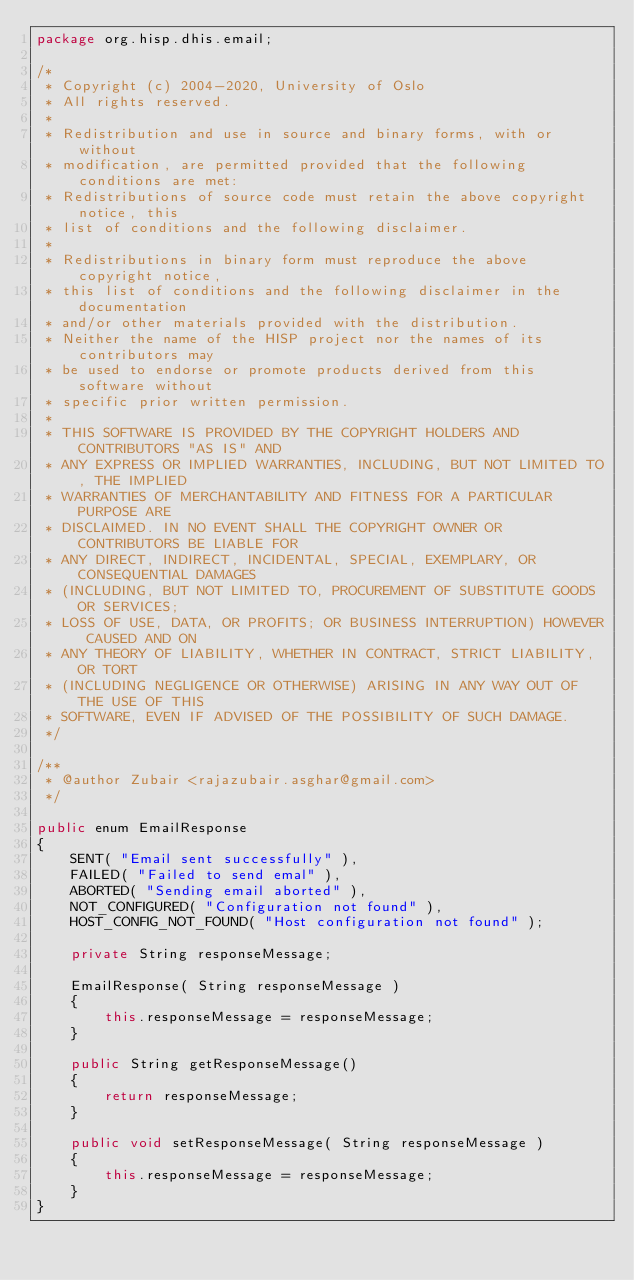Convert code to text. <code><loc_0><loc_0><loc_500><loc_500><_Java_>package org.hisp.dhis.email;

/*
 * Copyright (c) 2004-2020, University of Oslo
 * All rights reserved.
 *
 * Redistribution and use in source and binary forms, with or without
 * modification, are permitted provided that the following conditions are met:
 * Redistributions of source code must retain the above copyright notice, this
 * list of conditions and the following disclaimer.
 *
 * Redistributions in binary form must reproduce the above copyright notice,
 * this list of conditions and the following disclaimer in the documentation
 * and/or other materials provided with the distribution.
 * Neither the name of the HISP project nor the names of its contributors may
 * be used to endorse or promote products derived from this software without
 * specific prior written permission.
 *
 * THIS SOFTWARE IS PROVIDED BY THE COPYRIGHT HOLDERS AND CONTRIBUTORS "AS IS" AND
 * ANY EXPRESS OR IMPLIED WARRANTIES, INCLUDING, BUT NOT LIMITED TO, THE IMPLIED
 * WARRANTIES OF MERCHANTABILITY AND FITNESS FOR A PARTICULAR PURPOSE ARE
 * DISCLAIMED. IN NO EVENT SHALL THE COPYRIGHT OWNER OR CONTRIBUTORS BE LIABLE FOR
 * ANY DIRECT, INDIRECT, INCIDENTAL, SPECIAL, EXEMPLARY, OR CONSEQUENTIAL DAMAGES
 * (INCLUDING, BUT NOT LIMITED TO, PROCUREMENT OF SUBSTITUTE GOODS OR SERVICES;
 * LOSS OF USE, DATA, OR PROFITS; OR BUSINESS INTERRUPTION) HOWEVER CAUSED AND ON
 * ANY THEORY OF LIABILITY, WHETHER IN CONTRACT, STRICT LIABILITY, OR TORT
 * (INCLUDING NEGLIGENCE OR OTHERWISE) ARISING IN ANY WAY OUT OF THE USE OF THIS
 * SOFTWARE, EVEN IF ADVISED OF THE POSSIBILITY OF SUCH DAMAGE.
 */

/**
 * @author Zubair <rajazubair.asghar@gmail.com>
 */

public enum EmailResponse
{
    SENT( "Email sent successfully" ),
    FAILED( "Failed to send emal" ),
    ABORTED( "Sending email aborted" ),
    NOT_CONFIGURED( "Configuration not found" ),
    HOST_CONFIG_NOT_FOUND( "Host configuration not found" );

    private String responseMessage;

    EmailResponse( String responseMessage )
    {
        this.responseMessage = responseMessage;
    }

    public String getResponseMessage()
    {
        return responseMessage;
    }

    public void setResponseMessage( String responseMessage )
    {
        this.responseMessage = responseMessage;
    }
}
</code> 